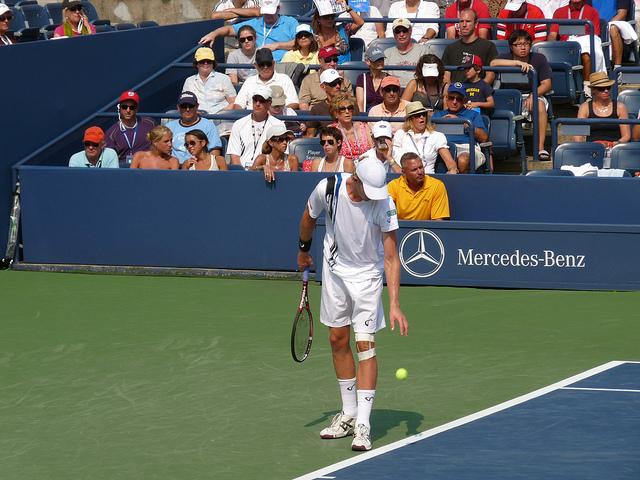What color are this man's shoes?
Write a very short answer. White. Has the man hit the ball?
Give a very brief answer. No. Why are there people in the bleachers behind the tennis player?
Keep it brief. Spectators. Is the audience very engaged in the tennis match?
Write a very short answer. Yes. What has the man tied on his leg?
Be succinct. Bandage. Are all the spectator seats full?
Write a very short answer. No. What kind of ball is the man bouncing?
Write a very short answer. Tennis. 